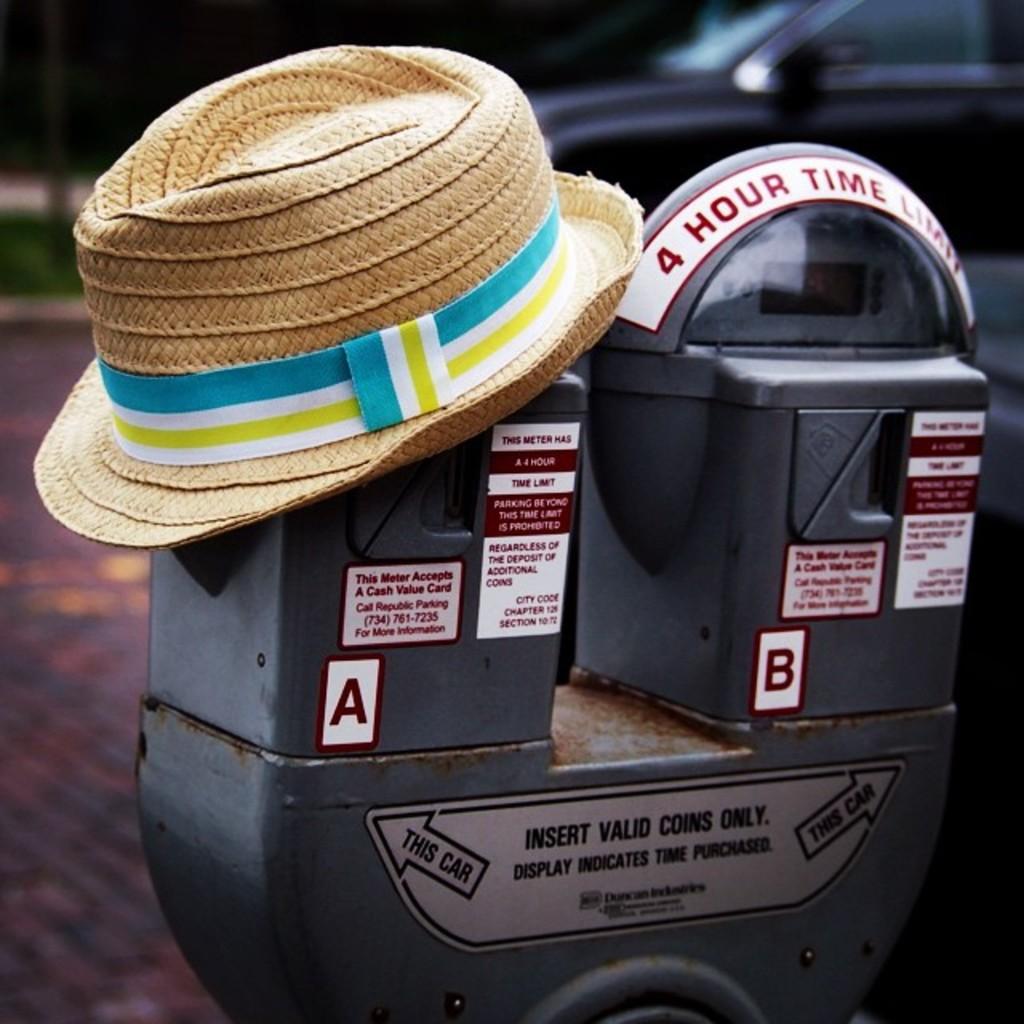What type of machine is this?
Provide a short and direct response. Parking meter. What is the time limit?
Offer a very short reply. 4 hours. 